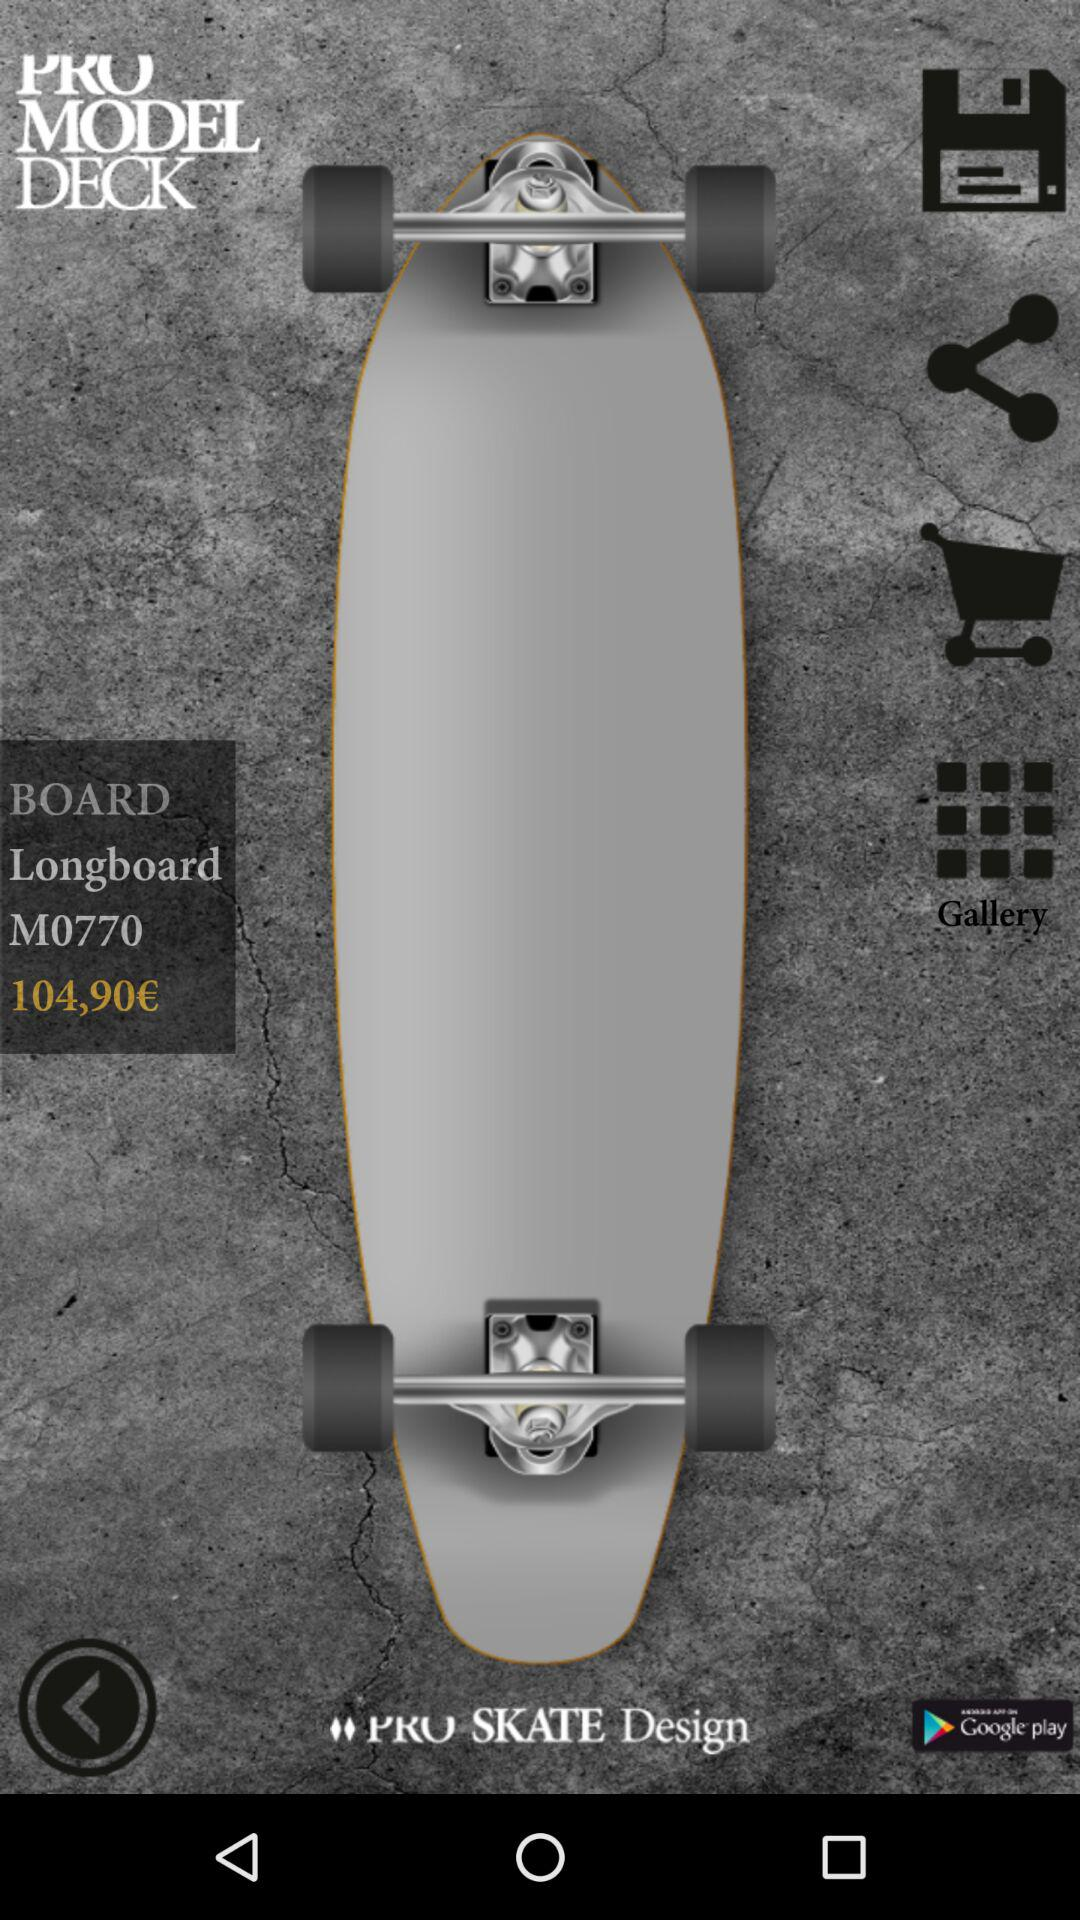What is the given model number? The given model number is "M0770". 